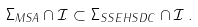<formula> <loc_0><loc_0><loc_500><loc_500>\Sigma _ { M S A } \cap \mathcal { I } \subset \Sigma _ { S S E H S D C } \cap \mathcal { I } \, .</formula> 